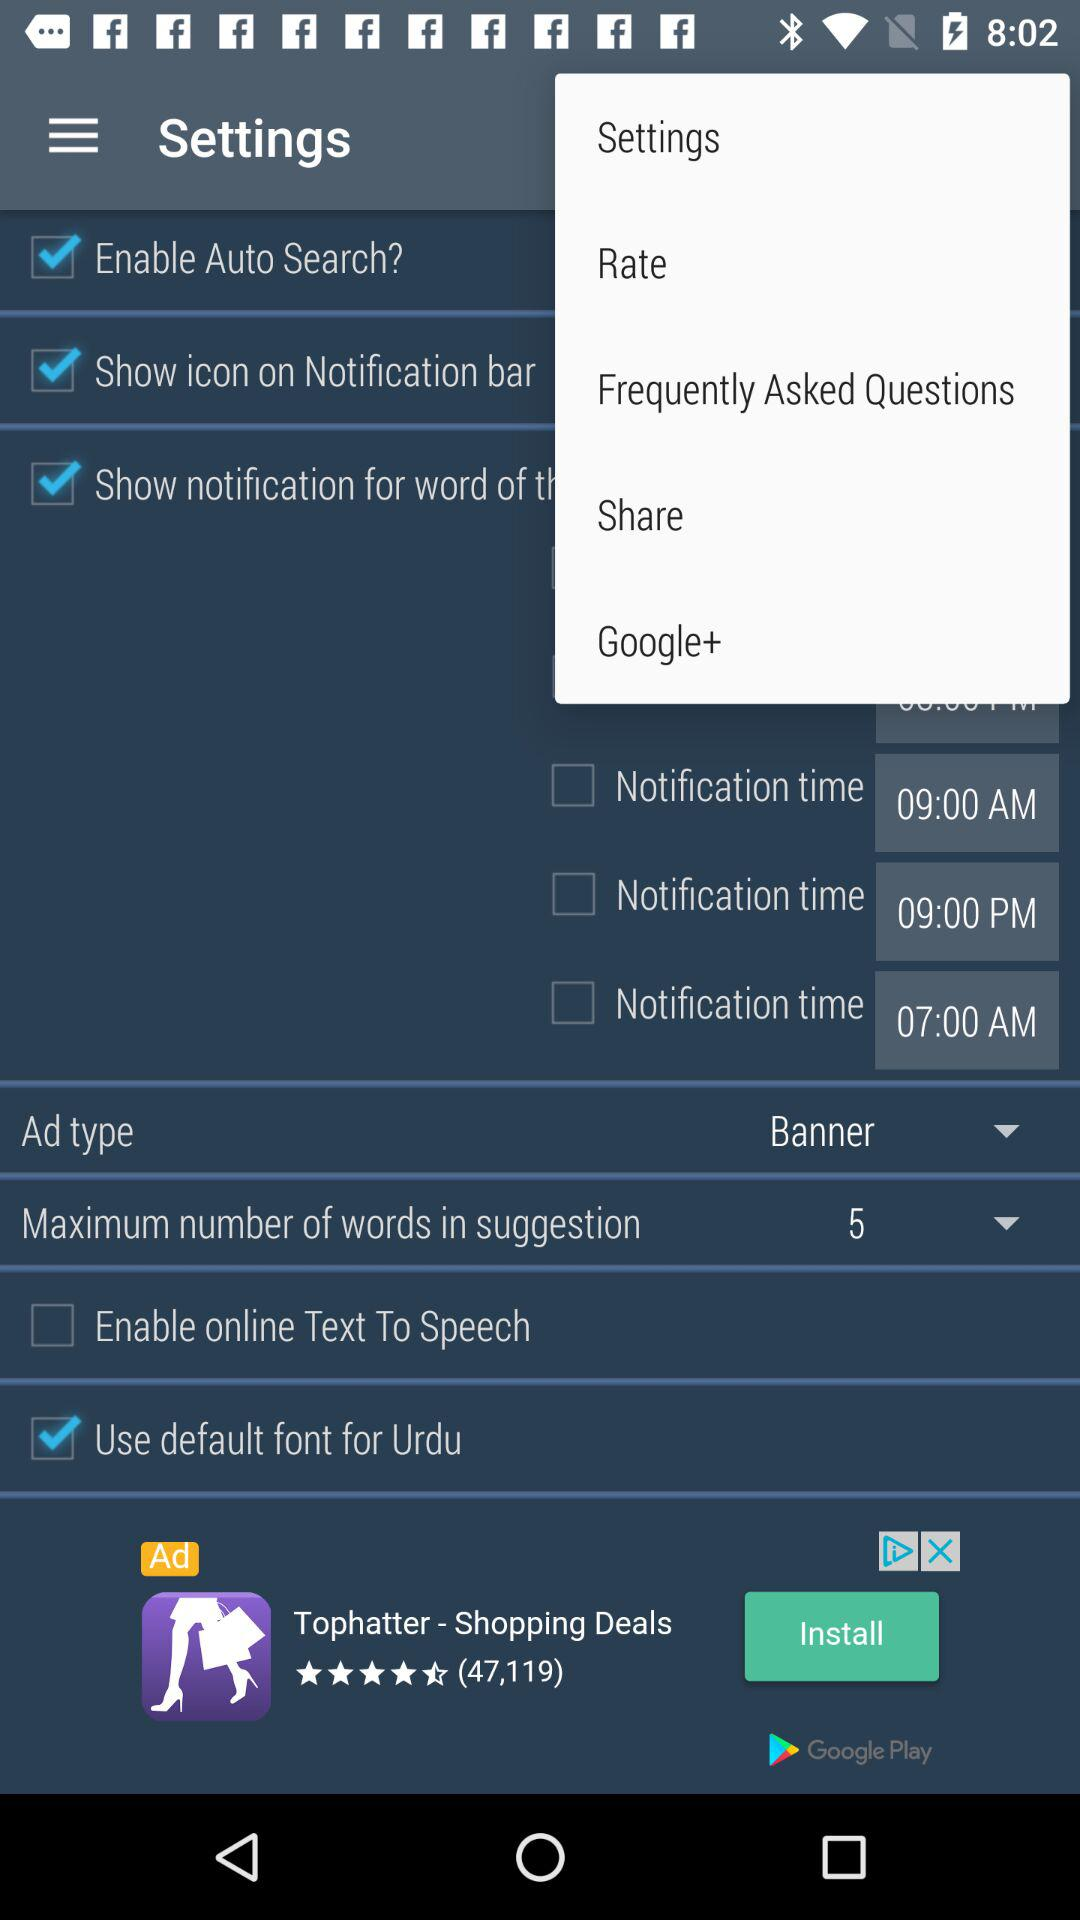What is the maximum number of words in suggestion? The maximum number of words in suggestion is 5. 